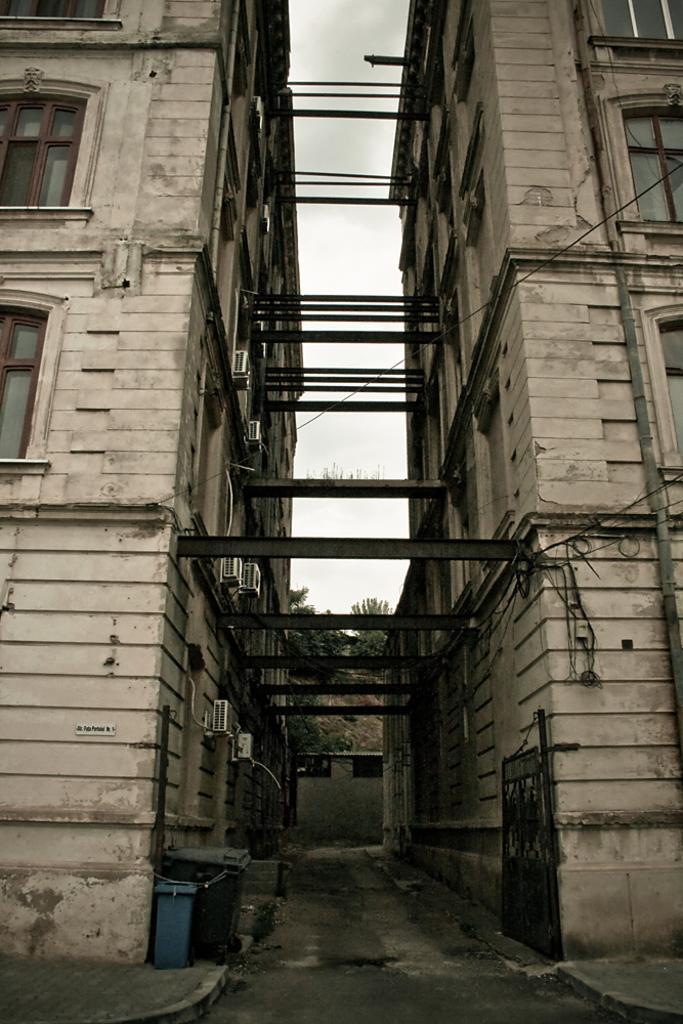How would you summarize this image in a sentence or two? In the image we can see some buildings and dustbin. Behind the building there are some trees and clouds and sky. 